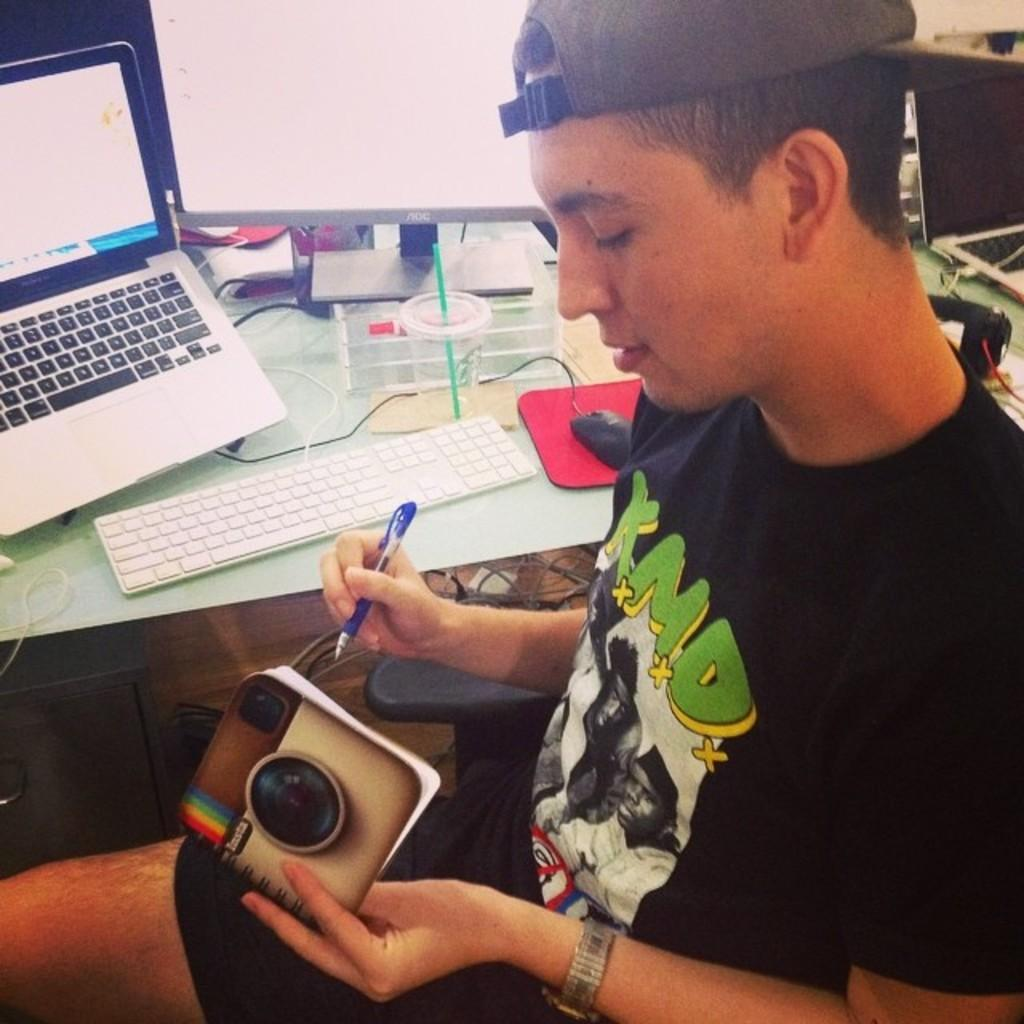Who is present in the image? There is a person in the image. What is the person holding? The person is holding a pen. Where is the person sitting? The person is sitting in front of a table. What electronic device is on the table? There is a laptop on the table. What is used for controlling the laptop? There is a mouse on the table. What is used for typing on the laptop? There is a keyboard on the table. Can you describe any other objects on the table? There are other unspecified things on the table. What type of produce is visible on the table in the image? There is no produce visible on the table in the image. Can you describe the duck that is sitting next to the person in the image? There is no duck present in the image. 